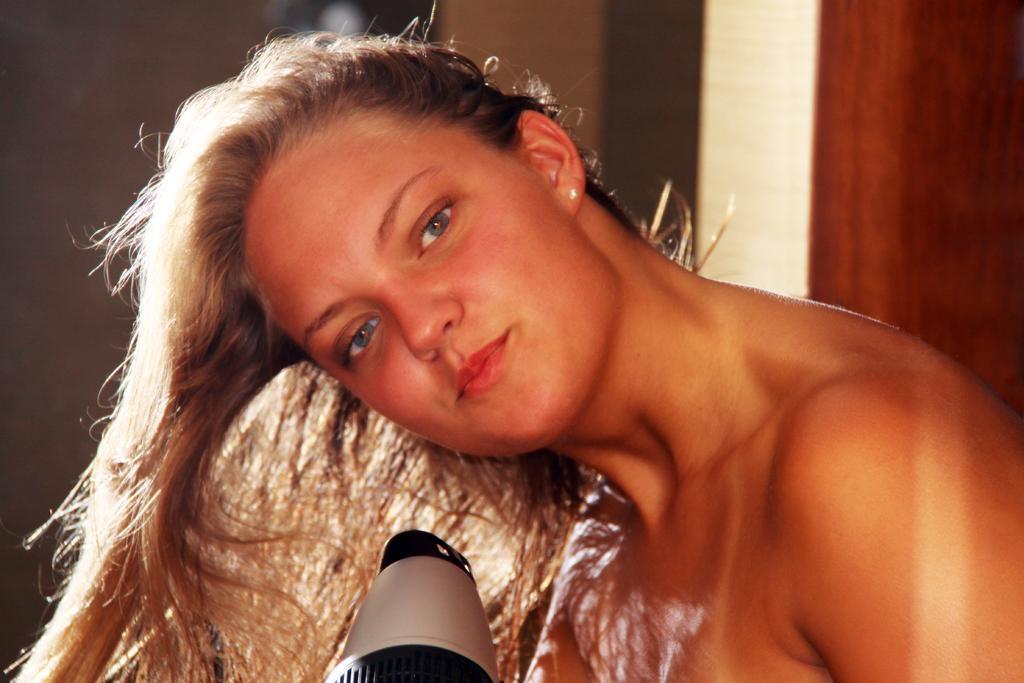Can you describe this image briefly? The picture consists of a woman blowing her hair. In the background we can see wall and door. 